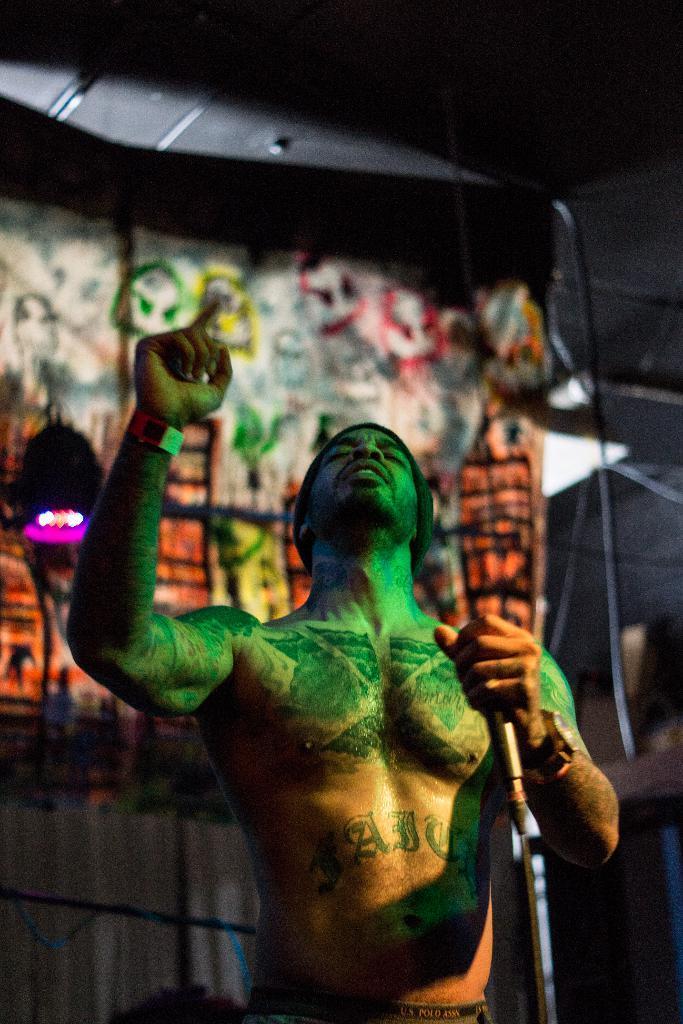Please provide a concise description of this image. Man in the middle of the picture is holding microphone in his hands and he is singing. Behind him, we see a sheet which is colorful and on top of the picture, we see black color tent like. 